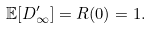Convert formula to latex. <formula><loc_0><loc_0><loc_500><loc_500>\mathbb { E } [ D _ { \infty } ^ { \prime } ] = R ( 0 ) = 1 .</formula> 